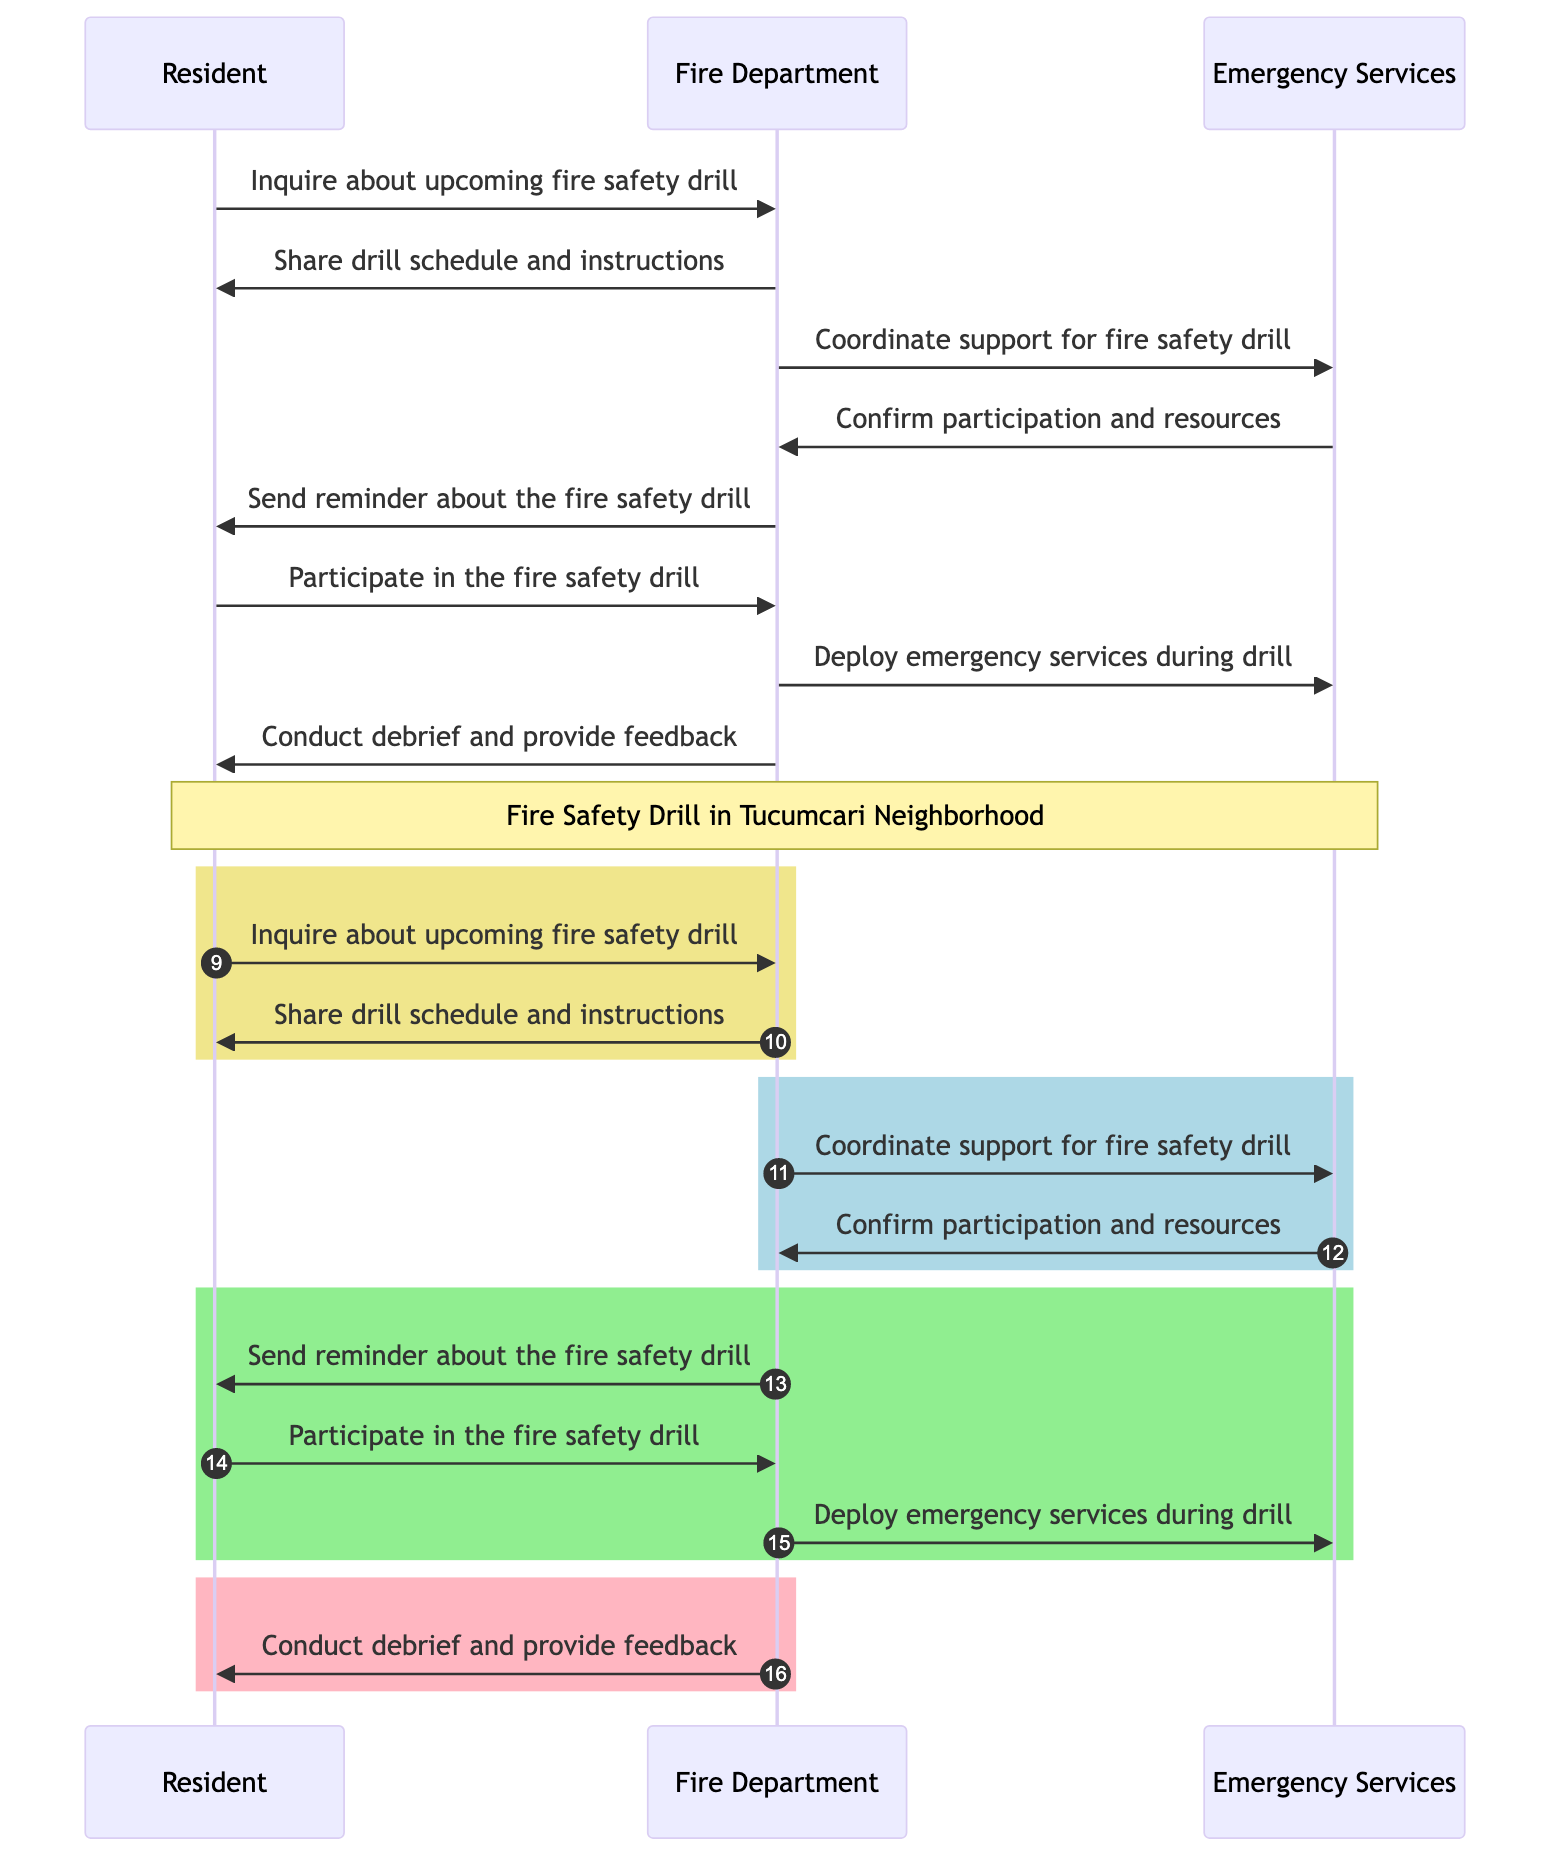What is the first action taken by the Resident? The diagram shows that the first action taken by the Resident is to inquire about the upcoming fire safety drill. This is indicated as the first message in the sequence.
Answer: Inquire about upcoming fire safety drill Who confirms participation and resources? According to the diagram, the Emergency Services confirm their participation and resources after the Fire Department coordinates support for the drill. This is represented as the second message from Emergency Services to the Fire Department.
Answer: Emergency Services What color represents the coordination phase of the drill? The coordination phase of the drill, which involves communication between the Fire Department and Emergency Services, is represented by a light blue rectangle in the diagram. This color is specified in the code.
Answer: Light blue How many distinct participants are involved in the sequence? The diagram includes three distinct participants: Resident, Fire Department, and Emergency Services. Each participant is represented at the top of the diagram, indicating their roles.
Answer: Three What is the final action taken in this sequence? The last action taken in the sequence is conducted by the Fire Department, which performs a debrief and provides feedback to the Resident. This is the last message shown in the diagram.
Answer: Conduct debrief and provide feedback What message is sent after the Resident participates in the drill? After the Resident participates in the drill, the Fire Department deploys emergency services during the drill. This message follows the participation action in the sequence.
Answer: Deploy emergency services during drill Which two entities coordinate directly in the drill? The Fire Department and Emergency Services are the two entities that coordinate directly regarding support for the fire safety drill, as indicated in their message exchange shown in the diagram.
Answer: Fire Department and Emergency Services What reminder is sent by the Fire Department to the Resident? The Fire Department sends a reminder about the fire safety drill to the Resident, as depicted in the sequence right before the Resident’s participation.
Answer: Send reminder about the fire safety drill 